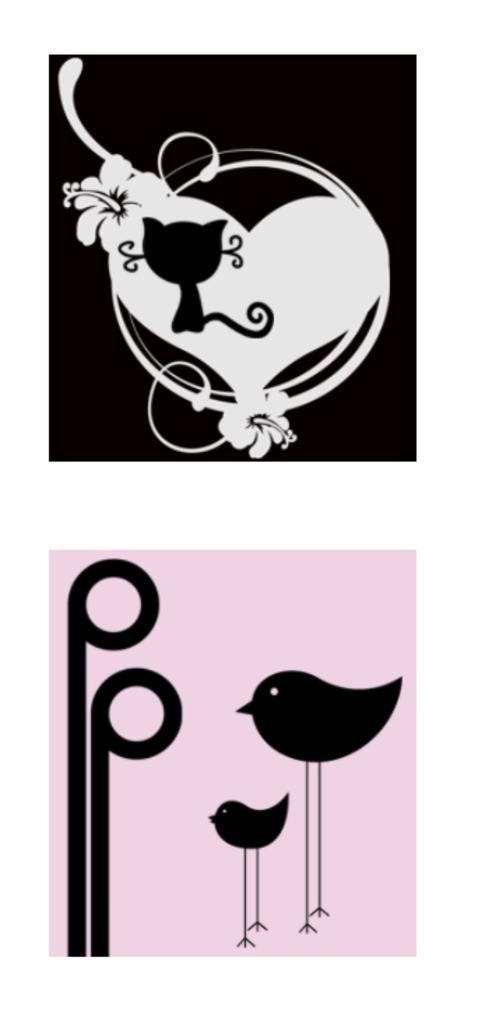What type of image is being described? The image is a collage. What type of animal is depicted in the collage? There is a clipart of a cat in the image. What symbol is included in the collage? There is a clipart of a heart in the image. What type of plants are included in the collage? There are cliparts of flowers in the image. What type of living organisms are included in the collage? There are cliparts of birds in the image. Where is the cemetery located in the image? There is no cemetery present in the image; it is a collage featuring clipart of a cat, a heart, flowers, and birds. How many trucks are visible in the image? There are no trucks present in the image. Who is the son of the cat in the image? There is no son mentioned or depicted in the image, as it features a cat as a clipart. 